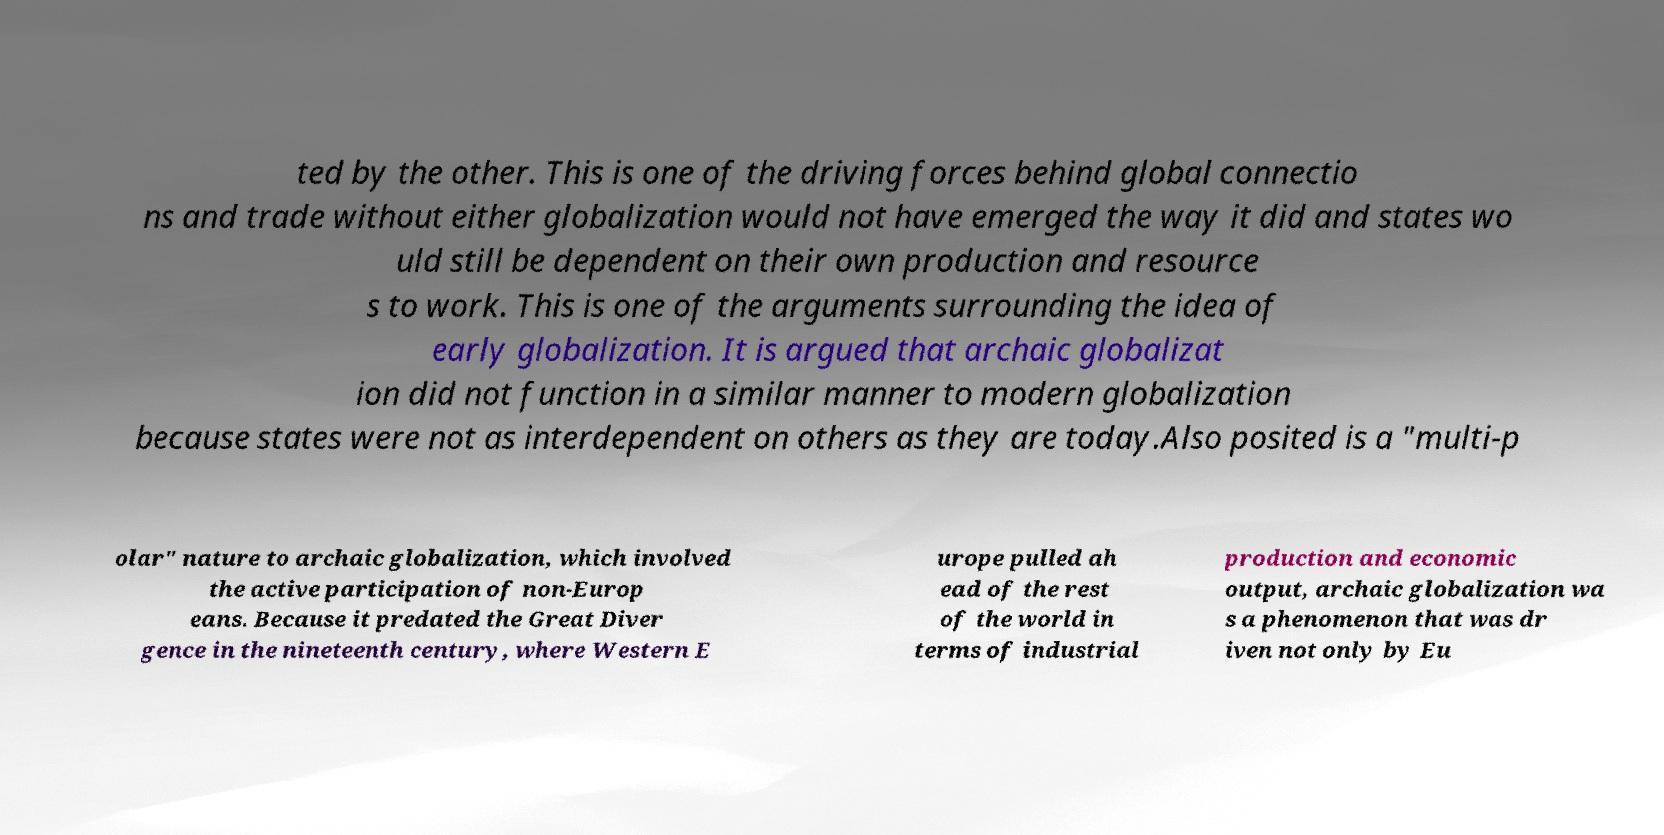Please identify and transcribe the text found in this image. ted by the other. This is one of the driving forces behind global connectio ns and trade without either globalization would not have emerged the way it did and states wo uld still be dependent on their own production and resource s to work. This is one of the arguments surrounding the idea of early globalization. It is argued that archaic globalizat ion did not function in a similar manner to modern globalization because states were not as interdependent on others as they are today.Also posited is a "multi-p olar" nature to archaic globalization, which involved the active participation of non-Europ eans. Because it predated the Great Diver gence in the nineteenth century, where Western E urope pulled ah ead of the rest of the world in terms of industrial production and economic output, archaic globalization wa s a phenomenon that was dr iven not only by Eu 